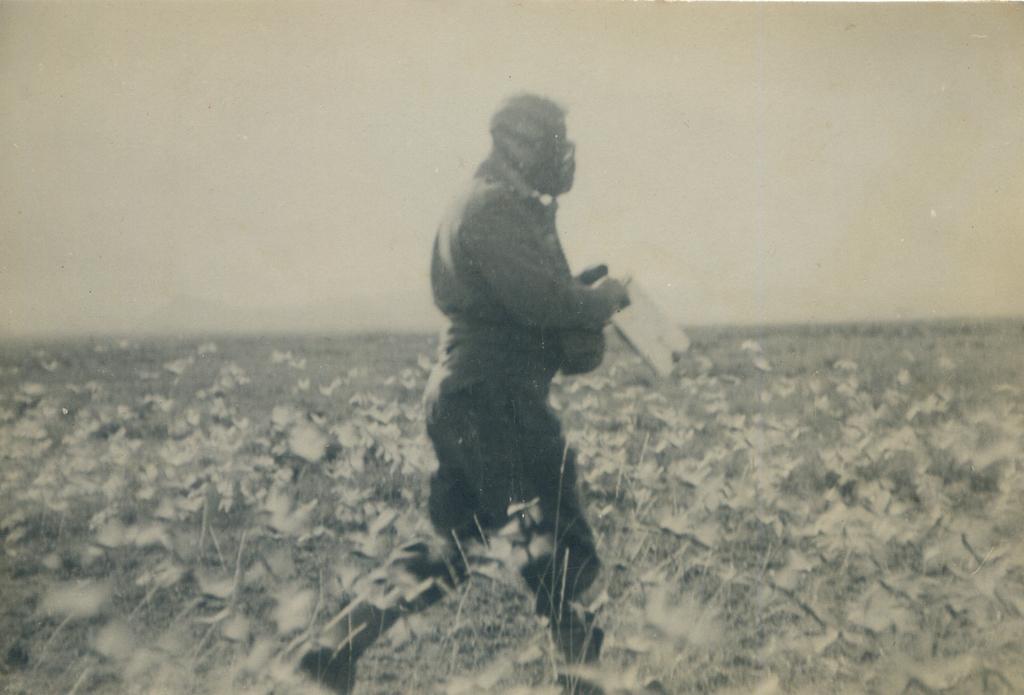Please provide a concise description of this image. This person is walking and holding an object. Here we can see plants. 